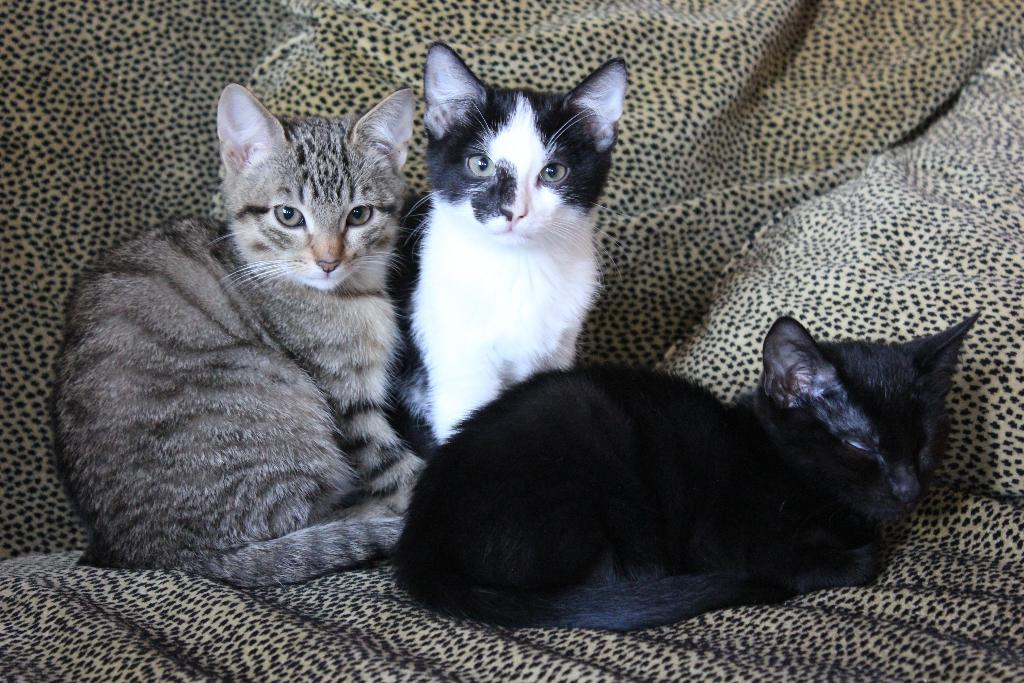How many cats are in the image? There are three cats in the image. What are the colors of the cats? One cat is black, one is gray, and one is black and white. Where are the cats located in the image? The cats are on a blanket. What language do the cats speak in the image? Cats do not speak human languages, so there is no language spoken by the cats in the image. 